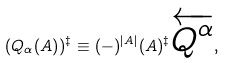Convert formula to latex. <formula><loc_0><loc_0><loc_500><loc_500>( Q _ { \alpha } ( A ) ) ^ { \ddagger } \equiv ( - ) ^ { | A | } ( A ) ^ { \ddagger } \overleftarrow { Q ^ { \alpha } } ,</formula> 